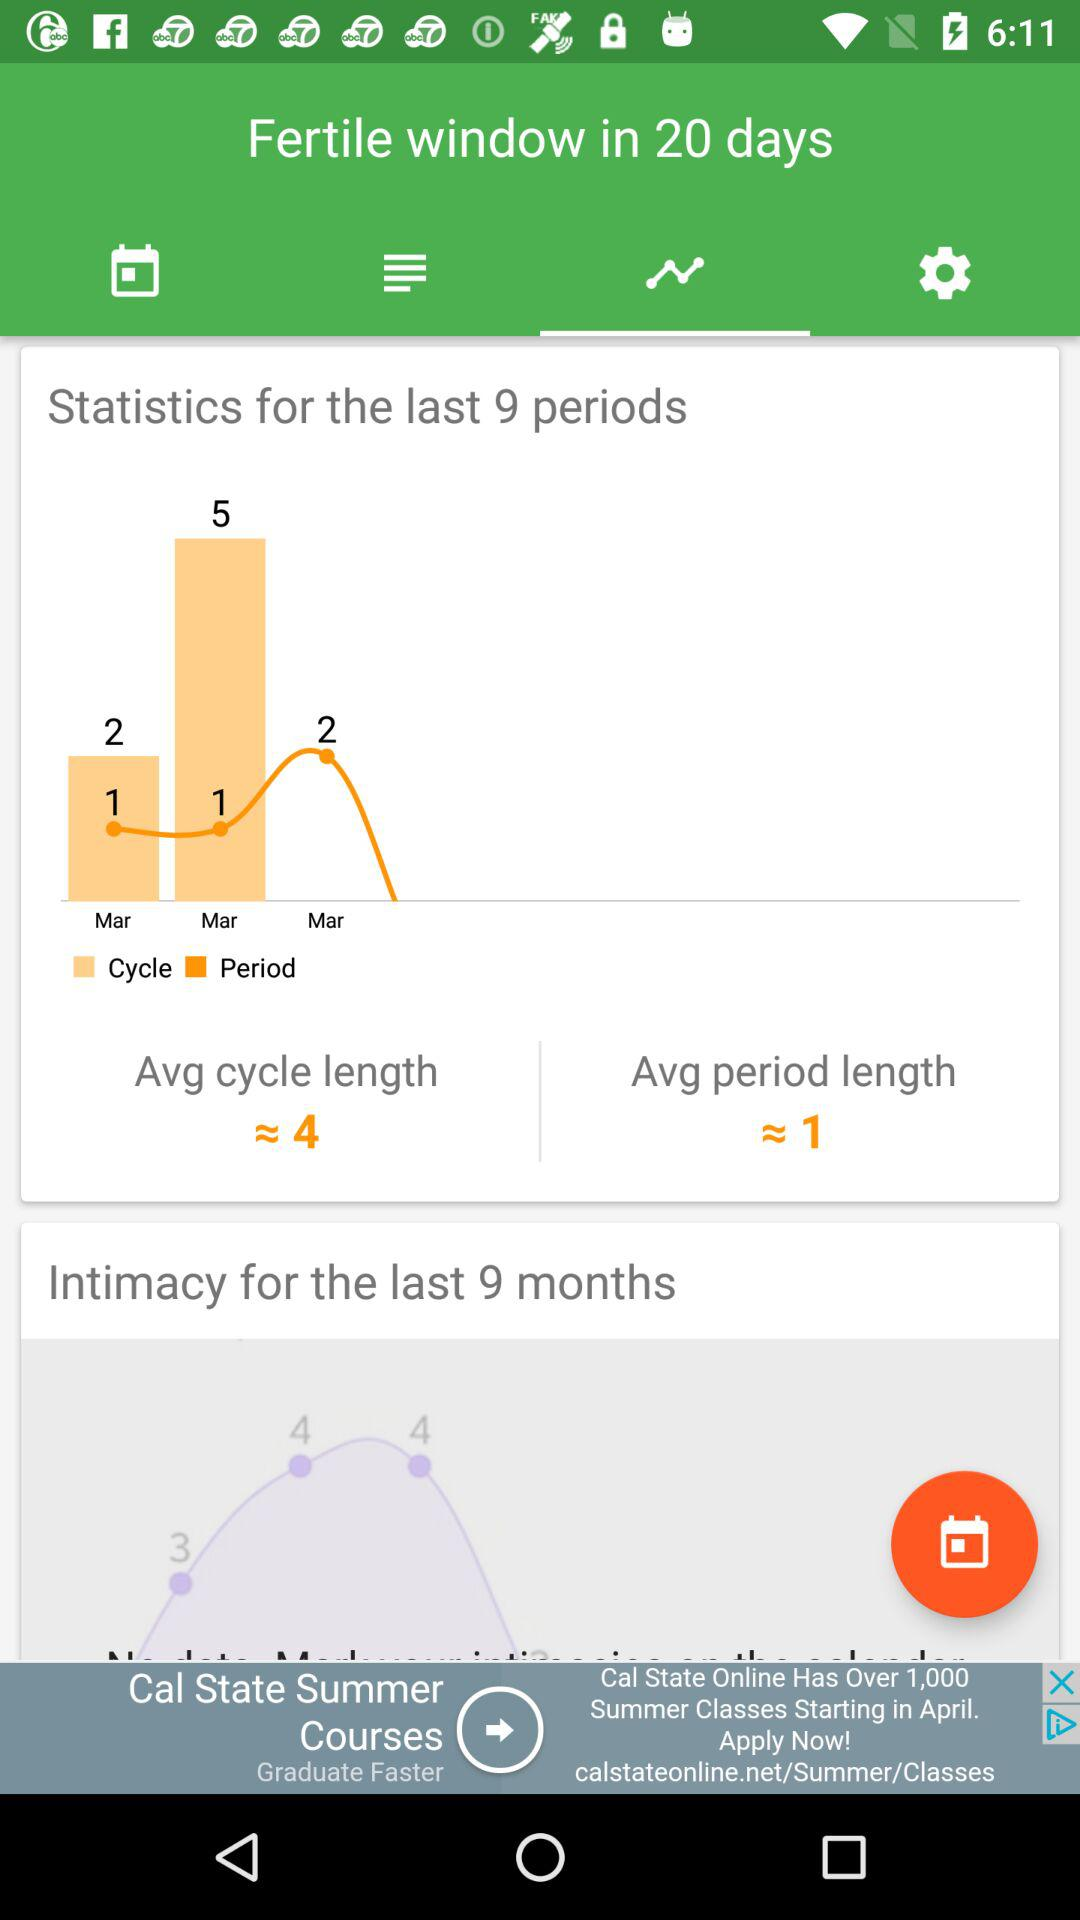How many days is the average period length?
Answer the question using a single word or phrase. 1 